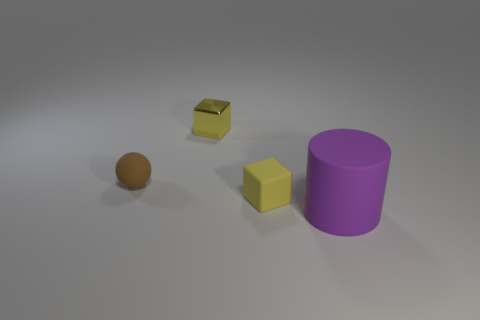Are the object that is to the left of the metal object and the small yellow block in front of the ball made of the same material?
Keep it short and to the point. Yes. What shape is the matte thing behind the yellow rubber block?
Your response must be concise. Sphere. What number of objects are tiny metallic blocks or tiny yellow blocks that are behind the tiny rubber ball?
Provide a short and direct response. 1. Are there an equal number of yellow cubes to the right of the yellow matte thing and small yellow metal objects that are in front of the tiny sphere?
Give a very brief answer. Yes. How many large purple things are to the left of the matte block?
Provide a succinct answer. 0. How many things are either large purple matte things or tiny things?
Offer a very short reply. 4. What number of purple rubber things are the same size as the brown matte thing?
Provide a succinct answer. 0. What shape is the small object that is left of the yellow cube to the left of the tiny yellow rubber thing?
Provide a short and direct response. Sphere. Is the number of brown metal cylinders less than the number of tiny brown spheres?
Your answer should be very brief. Yes. What is the color of the tiny thing to the left of the tiny metal cube?
Make the answer very short. Brown. 